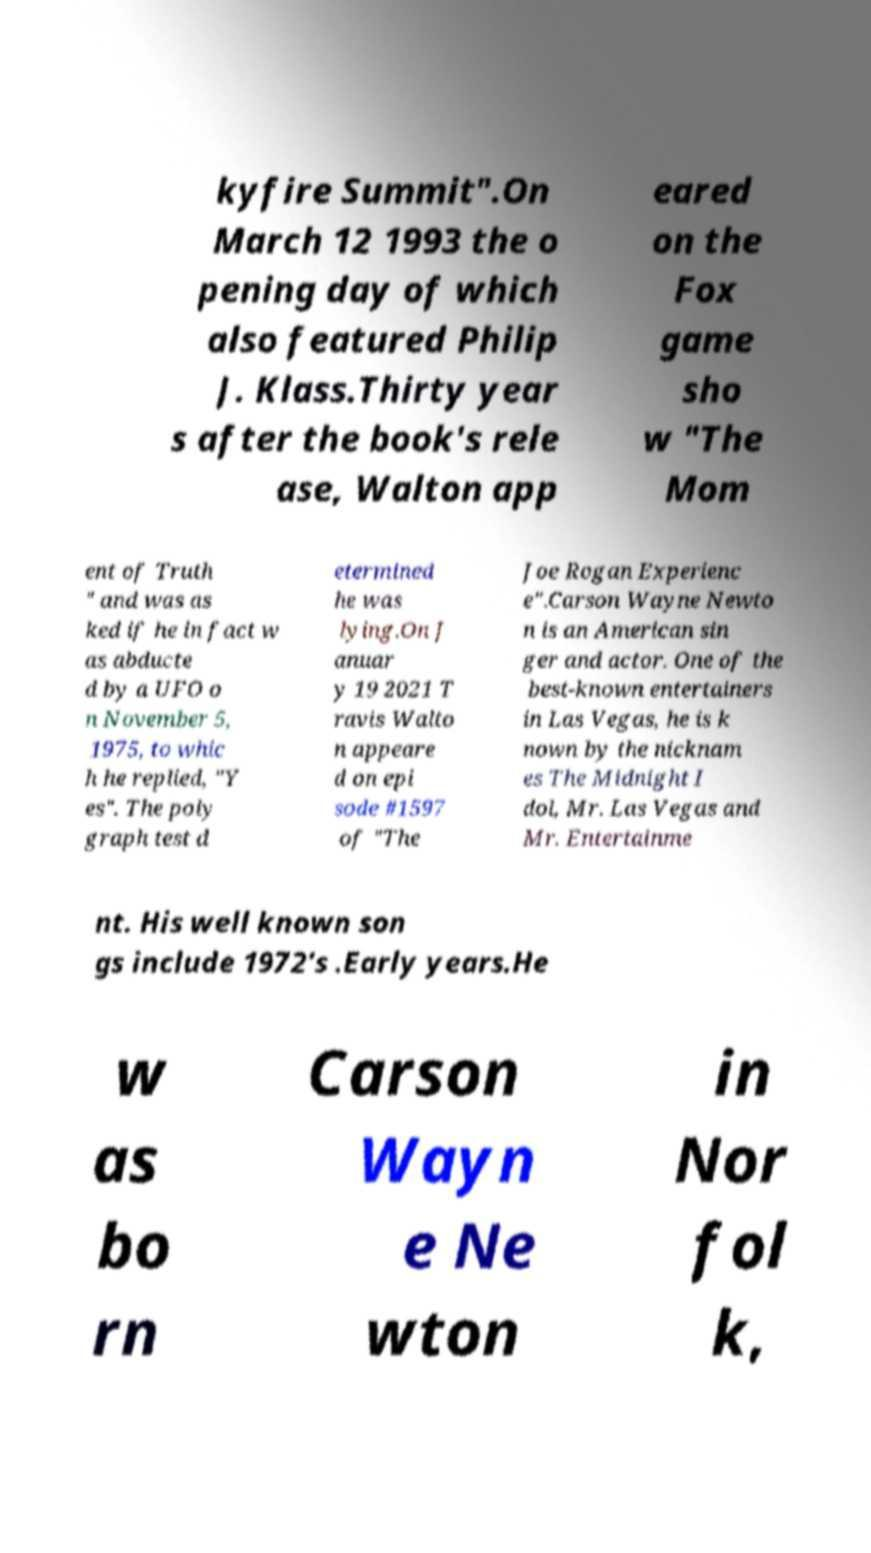What messages or text are displayed in this image? I need them in a readable, typed format. kyfire Summit".On March 12 1993 the o pening day of which also featured Philip J. Klass.Thirty year s after the book's rele ase, Walton app eared on the Fox game sho w "The Mom ent of Truth " and was as ked if he in fact w as abducte d by a UFO o n November 5, 1975, to whic h he replied, "Y es". The poly graph test d etermined he was lying.On J anuar y 19 2021 T ravis Walto n appeare d on epi sode #1597 of "The Joe Rogan Experienc e".Carson Wayne Newto n is an American sin ger and actor. One of the best-known entertainers in Las Vegas, he is k nown by the nicknam es The Midnight I dol, Mr. Las Vegas and Mr. Entertainme nt. His well known son gs include 1972's .Early years.He w as bo rn Carson Wayn e Ne wton in Nor fol k, 